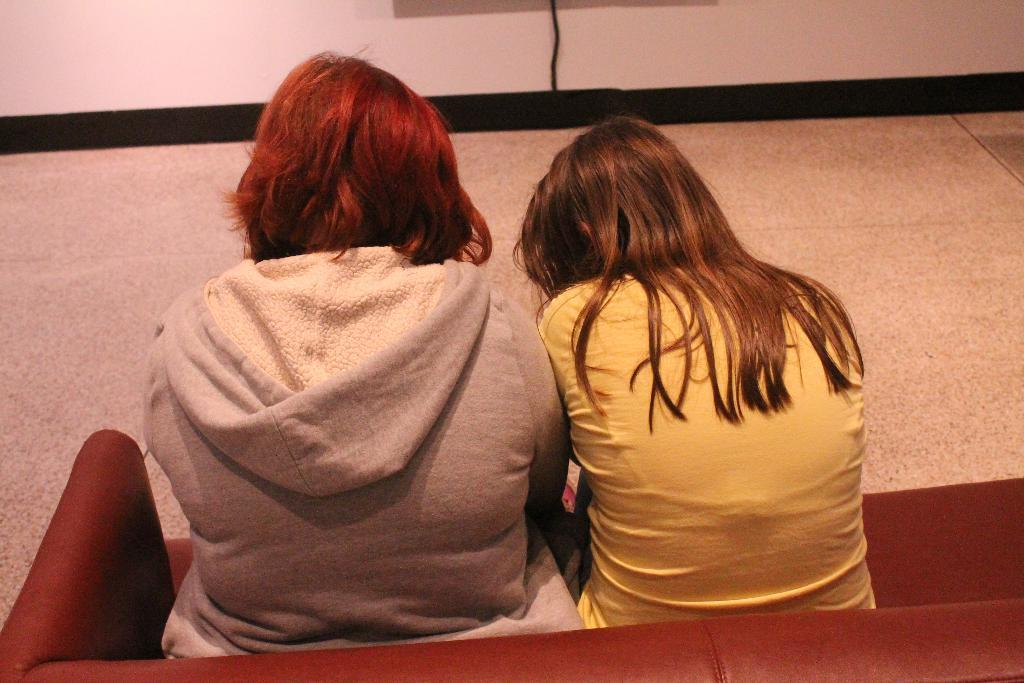How many people are in the image? There are two people in the image. What are the people sitting on? The people are sitting on a maroon color couch. Can you describe the clothing of the first person? One person is wearing a yellow dress. How about the clothing of the second person? The other person is wearing an ash color dress. What can be seen in the background of the image? There is a floor visible in the background, and there is a white wall in the background. What type of lace can be seen on the receipt in the image? There is no receipt present in the image, and therefore no lace can be observed. 